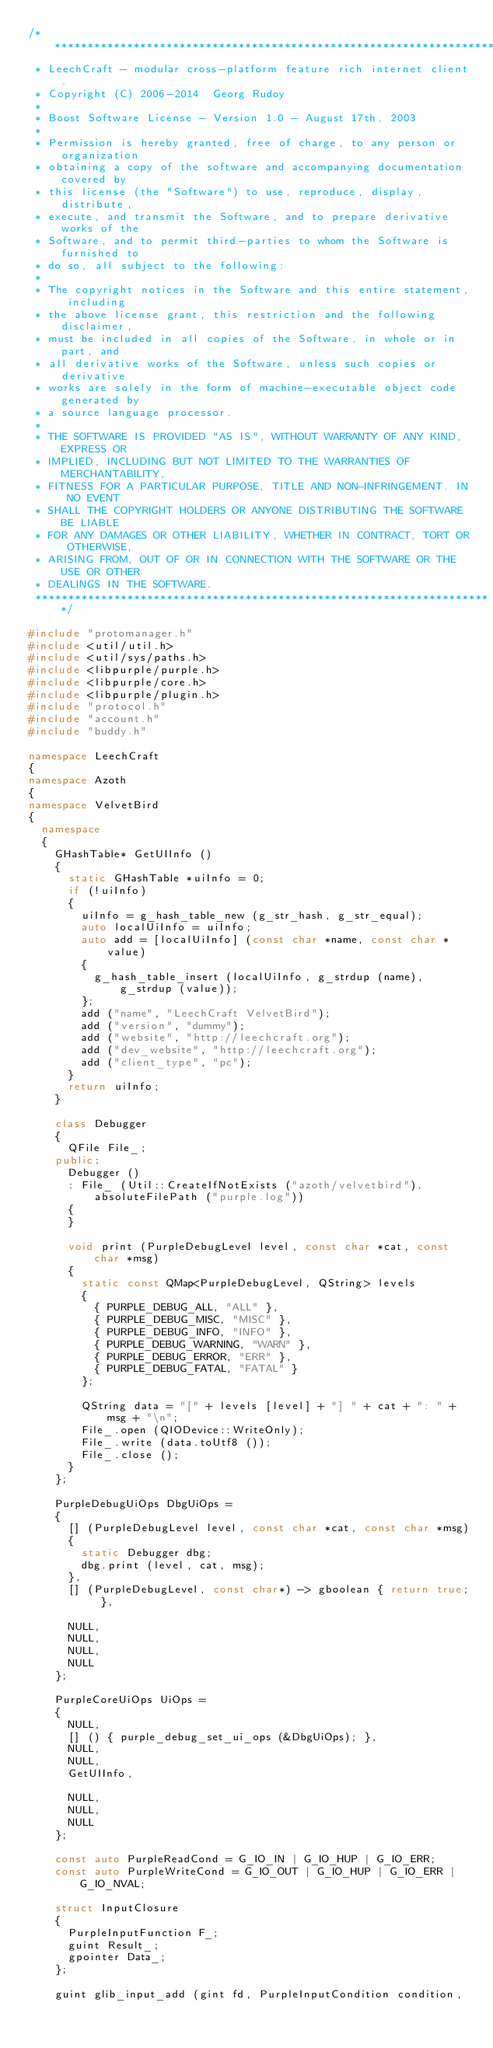<code> <loc_0><loc_0><loc_500><loc_500><_C++_>/**********************************************************************
 * LeechCraft - modular cross-platform feature rich internet client.
 * Copyright (C) 2006-2014  Georg Rudoy
 *
 * Boost Software License - Version 1.0 - August 17th, 2003
 *
 * Permission is hereby granted, free of charge, to any person or organization
 * obtaining a copy of the software and accompanying documentation covered by
 * this license (the "Software") to use, reproduce, display, distribute,
 * execute, and transmit the Software, and to prepare derivative works of the
 * Software, and to permit third-parties to whom the Software is furnished to
 * do so, all subject to the following:
 *
 * The copyright notices in the Software and this entire statement, including
 * the above license grant, this restriction and the following disclaimer,
 * must be included in all copies of the Software, in whole or in part, and
 * all derivative works of the Software, unless such copies or derivative
 * works are solely in the form of machine-executable object code generated by
 * a source language processor.
 *
 * THE SOFTWARE IS PROVIDED "AS IS", WITHOUT WARRANTY OF ANY KIND, EXPRESS OR
 * IMPLIED, INCLUDING BUT NOT LIMITED TO THE WARRANTIES OF MERCHANTABILITY,
 * FITNESS FOR A PARTICULAR PURPOSE, TITLE AND NON-INFRINGEMENT. IN NO EVENT
 * SHALL THE COPYRIGHT HOLDERS OR ANYONE DISTRIBUTING THE SOFTWARE BE LIABLE
 * FOR ANY DAMAGES OR OTHER LIABILITY, WHETHER IN CONTRACT, TORT OR OTHERWISE,
 * ARISING FROM, OUT OF OR IN CONNECTION WITH THE SOFTWARE OR THE USE OR OTHER
 * DEALINGS IN THE SOFTWARE.
 **********************************************************************/

#include "protomanager.h"
#include <util/util.h>
#include <util/sys/paths.h>
#include <libpurple/purple.h>
#include <libpurple/core.h>
#include <libpurple/plugin.h>
#include "protocol.h"
#include "account.h"
#include "buddy.h"

namespace LeechCraft
{
namespace Azoth
{
namespace VelvetBird
{
	namespace
	{
		GHashTable* GetUIInfo ()
		{
			static GHashTable *uiInfo = 0;
			if (!uiInfo)
			{
				uiInfo = g_hash_table_new (g_str_hash, g_str_equal);
				auto localUiInfo = uiInfo;
				auto add = [localUiInfo] (const char *name, const char *value)
				{
					g_hash_table_insert (localUiInfo, g_strdup (name), g_strdup (value));
				};
				add ("name", "LeechCraft VelvetBird");
				add ("version", "dummy");
				add ("website", "http://leechcraft.org");
				add ("dev_website", "http://leechcraft.org");
				add ("client_type", "pc");
			}
			return uiInfo;
		}

		class Debugger
		{
			QFile File_;
		public:
			Debugger ()
			: File_ (Util::CreateIfNotExists ("azoth/velvetbird").absoluteFilePath ("purple.log"))
			{
			}

			void print (PurpleDebugLevel level, const char *cat, const char *msg)
			{
				static const QMap<PurpleDebugLevel, QString> levels
				{
					{ PURPLE_DEBUG_ALL, "ALL" },
					{ PURPLE_DEBUG_MISC, "MISC" },
					{ PURPLE_DEBUG_INFO, "INFO" },
					{ PURPLE_DEBUG_WARNING, "WARN" },
					{ PURPLE_DEBUG_ERROR, "ERR" },
					{ PURPLE_DEBUG_FATAL, "FATAL" }
				};

				QString data = "[" + levels [level] + "] " + cat + ": " + msg + "\n";
				File_.open (QIODevice::WriteOnly);
				File_.write (data.toUtf8 ());
				File_.close ();
			}
		};

		PurpleDebugUiOps DbgUiOps =
		{
			[] (PurpleDebugLevel level, const char *cat, const char *msg)
			{
				static Debugger dbg;
				dbg.print (level, cat, msg);
			},
			[] (PurpleDebugLevel, const char*) -> gboolean { return true; },

			NULL,
			NULL,
			NULL,
			NULL
		};

		PurpleCoreUiOps UiOps =
		{
			NULL,
			[] () { purple_debug_set_ui_ops (&DbgUiOps); },
			NULL,
			NULL,
			GetUIInfo,

			NULL,
			NULL,
			NULL
		};

		const auto PurpleReadCond = G_IO_IN | G_IO_HUP | G_IO_ERR;
		const auto PurpleWriteCond = G_IO_OUT | G_IO_HUP | G_IO_ERR | G_IO_NVAL;

		struct InputClosure
		{
			PurpleInputFunction F_;
			guint Result_;
			gpointer Data_;
		};

		guint glib_input_add (gint fd, PurpleInputCondition condition,</code> 